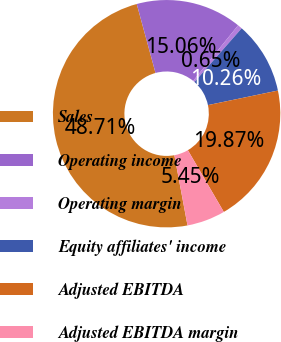<chart> <loc_0><loc_0><loc_500><loc_500><pie_chart><fcel>Sales<fcel>Operating income<fcel>Operating margin<fcel>Equity affiliates' income<fcel>Adjusted EBITDA<fcel>Adjusted EBITDA margin<nl><fcel>48.71%<fcel>15.06%<fcel>0.65%<fcel>10.26%<fcel>19.87%<fcel>5.45%<nl></chart> 